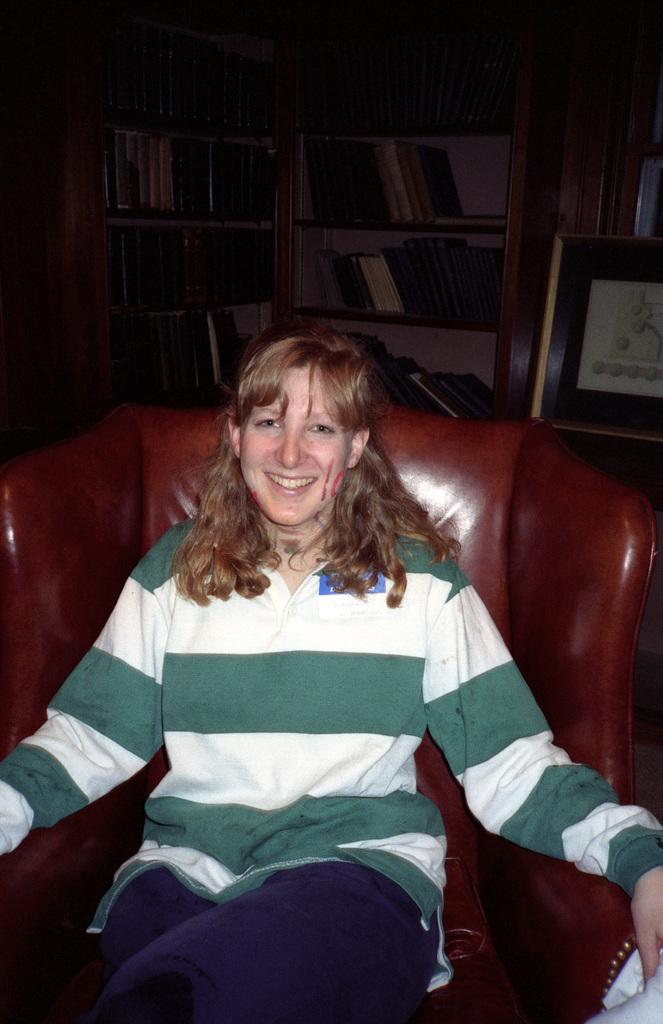Who is the main subject in the image? There is a woman in the image. What is the woman doing in the image? The woman is sitting on a chair and smiling. What can be seen in the background of the image? There are bookshelves in the background of the image. What is stored on the bookshelves? The bookshelves contain books. Can you see a frog jumping on the bookshelves in the image? No, there is no frog present in the image. 